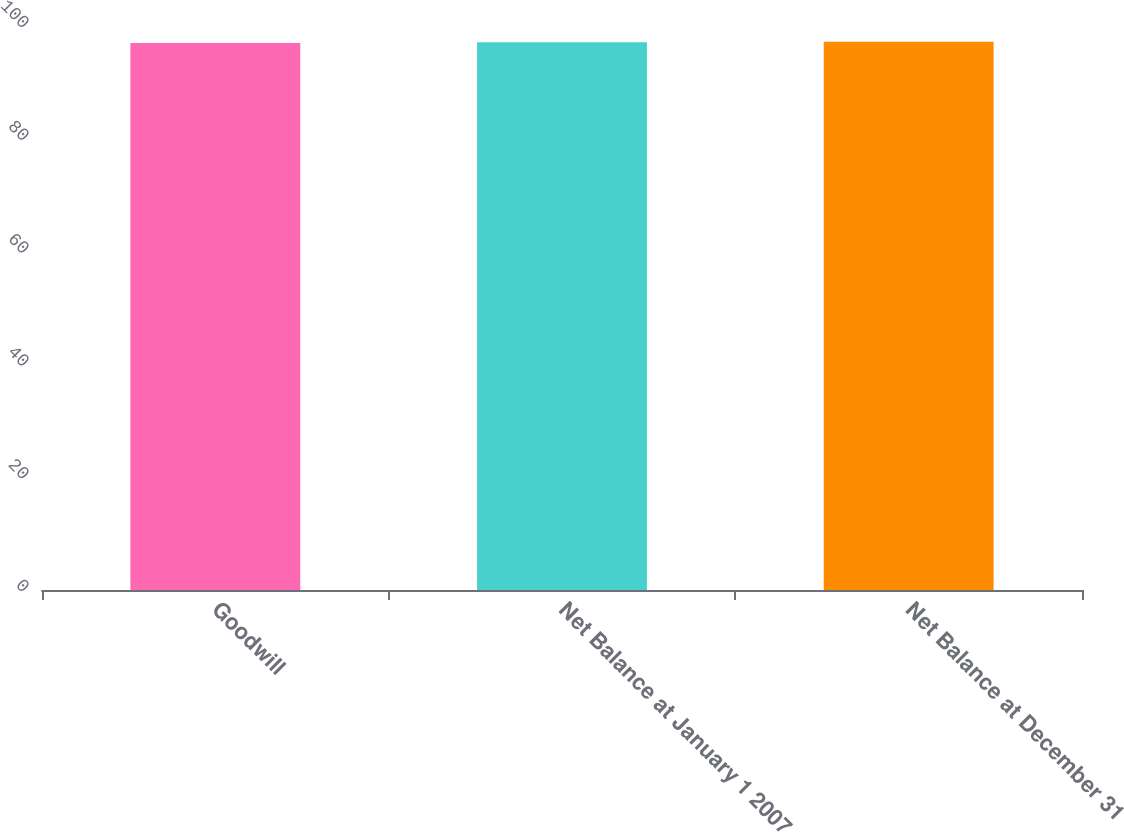Convert chart to OTSL. <chart><loc_0><loc_0><loc_500><loc_500><bar_chart><fcel>Goodwill<fcel>Net Balance at January 1 2007<fcel>Net Balance at December 31<nl><fcel>97<fcel>97.1<fcel>97.2<nl></chart> 